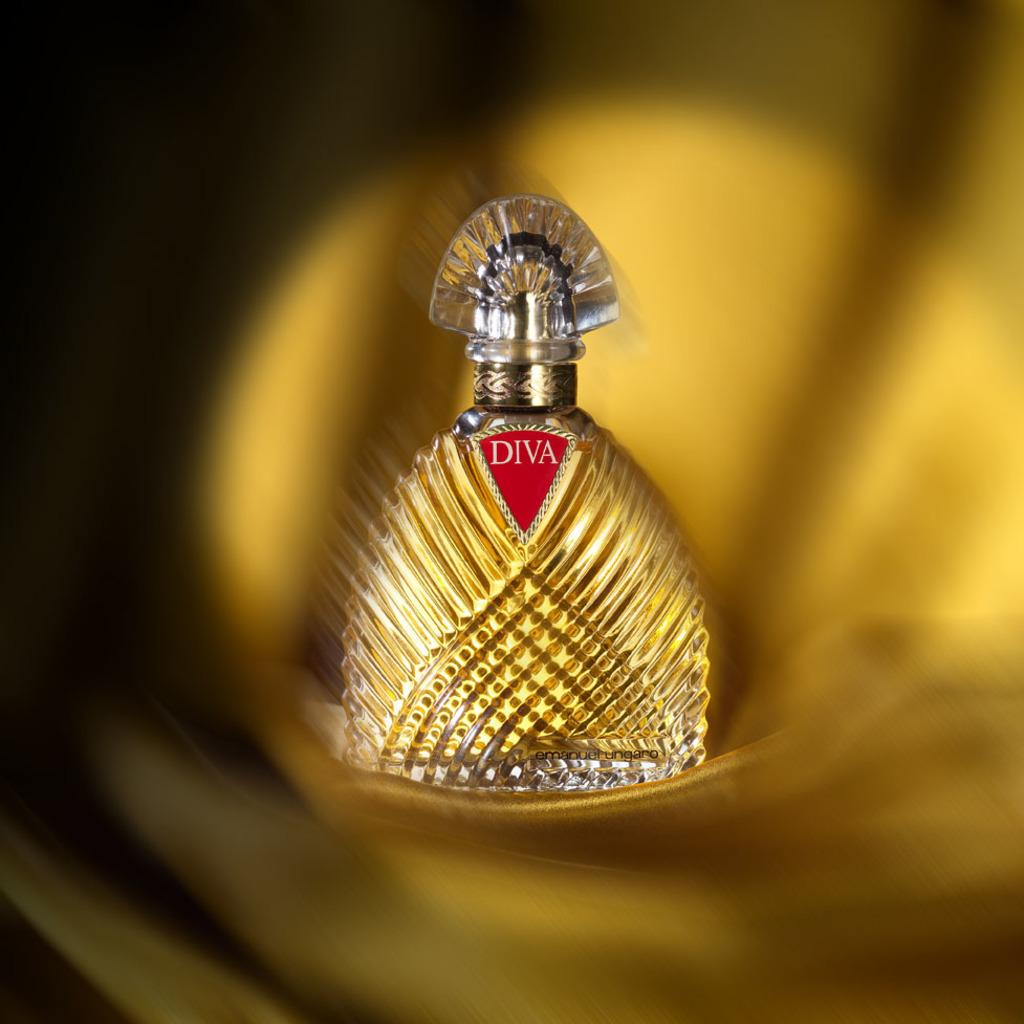What is the main object in the middle of the image? There is a bottle in the middle of the image. What can be seen on the bottle? The bottle has a red color logo on it. How would you describe the background of the image? The background of the image is blurred. What is your dad saying in the image? There is no person or conversation depicted in the image, so it is not possible to determine what your dad might be saying. 